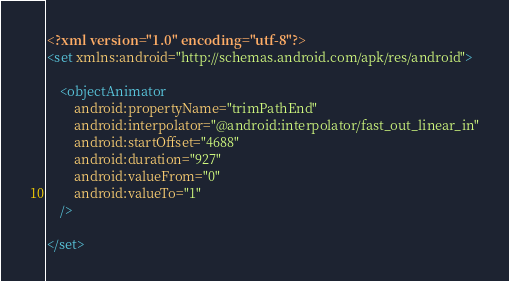<code> <loc_0><loc_0><loc_500><loc_500><_XML_><?xml version="1.0" encoding="utf-8"?>
<set xmlns:android="http://schemas.android.com/apk/res/android">

    <objectAnimator
        android:propertyName="trimPathEnd"
        android:interpolator="@android:interpolator/fast_out_linear_in"
        android:startOffset="4688"
        android:duration="927"
        android:valueFrom="0"
        android:valueTo="1"
    />

</set></code> 